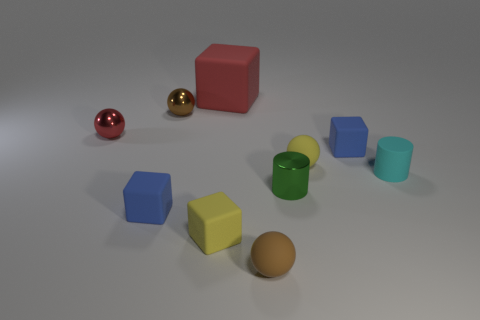Subtract all yellow cubes. How many brown spheres are left? 2 Subtract 1 cubes. How many cubes are left? 3 Subtract all small matte blocks. How many blocks are left? 1 Subtract all purple spheres. Subtract all blue blocks. How many spheres are left? 4 Subtract all yellow metal cylinders. Subtract all red matte objects. How many objects are left? 9 Add 1 tiny green objects. How many tiny green objects are left? 2 Add 1 small gray metallic blocks. How many small gray metallic blocks exist? 1 Subtract 0 blue cylinders. How many objects are left? 10 Subtract all cubes. How many objects are left? 6 